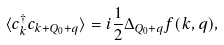Convert formula to latex. <formula><loc_0><loc_0><loc_500><loc_500>\langle c ^ { \dagger } _ { k } c _ { { k } + { Q } _ { 0 } + { q } } \rangle = i \frac { 1 } { 2 } \Delta _ { Q _ { 0 } + q } f ( { k } , { q } ) ,</formula> 